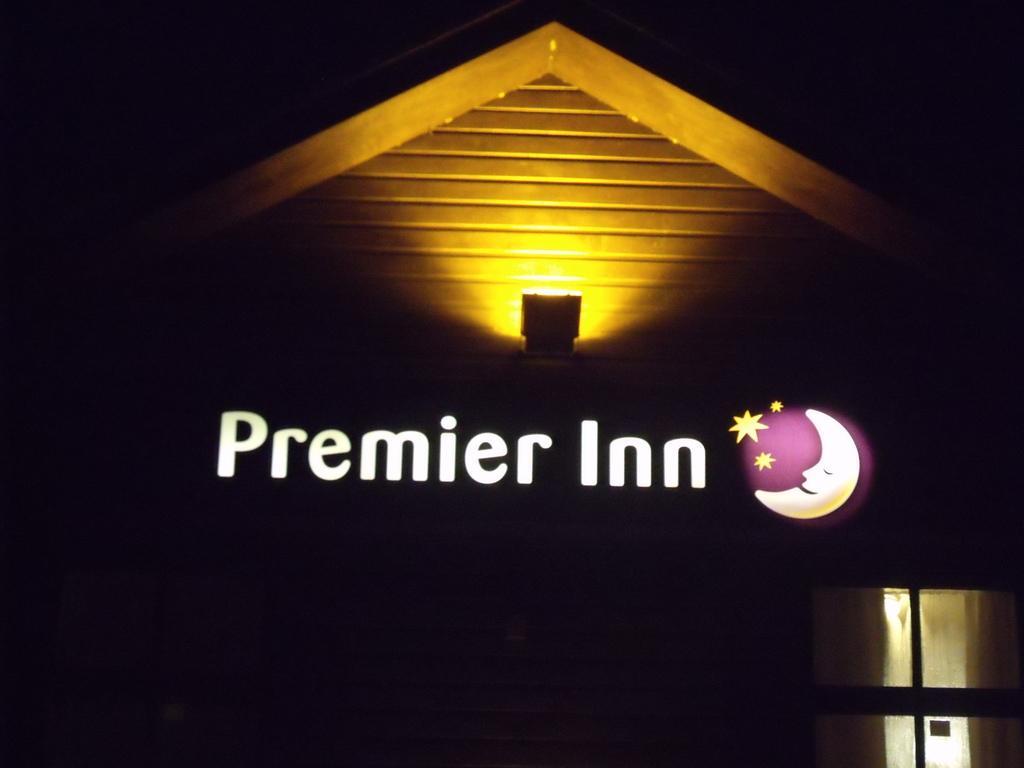Describe this image in one or two sentences. In this image we can see the front view of a house. There is a lamp on the metal rod. On the right side of the image there is a glass window. There are some text and watermark on the image. 